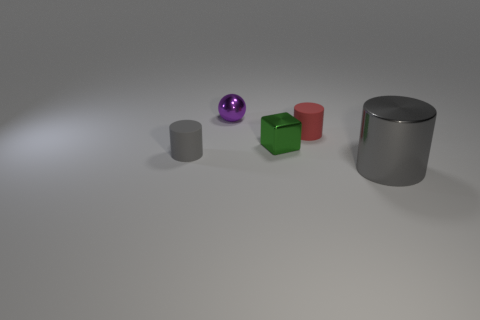Subtract all small cylinders. How many cylinders are left? 1 Subtract all gray cylinders. How many cylinders are left? 1 Add 1 tiny cubes. How many objects exist? 6 Subtract 2 cylinders. How many cylinders are left? 1 Subtract all blue cubes. How many gray cylinders are left? 2 Subtract all balls. How many objects are left? 4 Add 3 small things. How many small things are left? 7 Add 4 green shiny objects. How many green shiny objects exist? 5 Subtract 0 blue balls. How many objects are left? 5 Subtract all brown cubes. Subtract all gray spheres. How many cubes are left? 1 